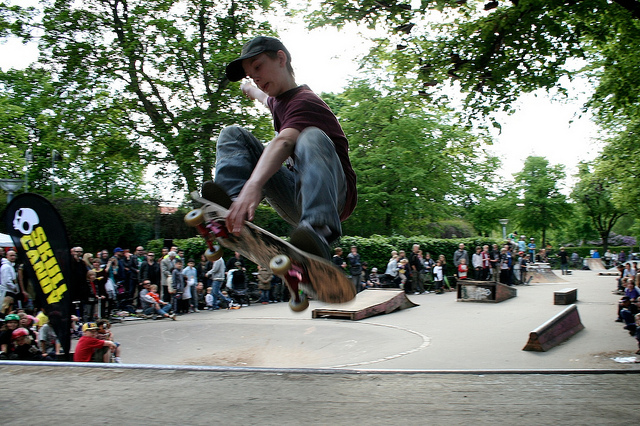Please transcribe the text information in this image. SKULL 